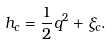Convert formula to latex. <formula><loc_0><loc_0><loc_500><loc_500>h _ { c } = \frac { 1 } { 2 } q ^ { 2 } + \xi _ { c } .</formula> 